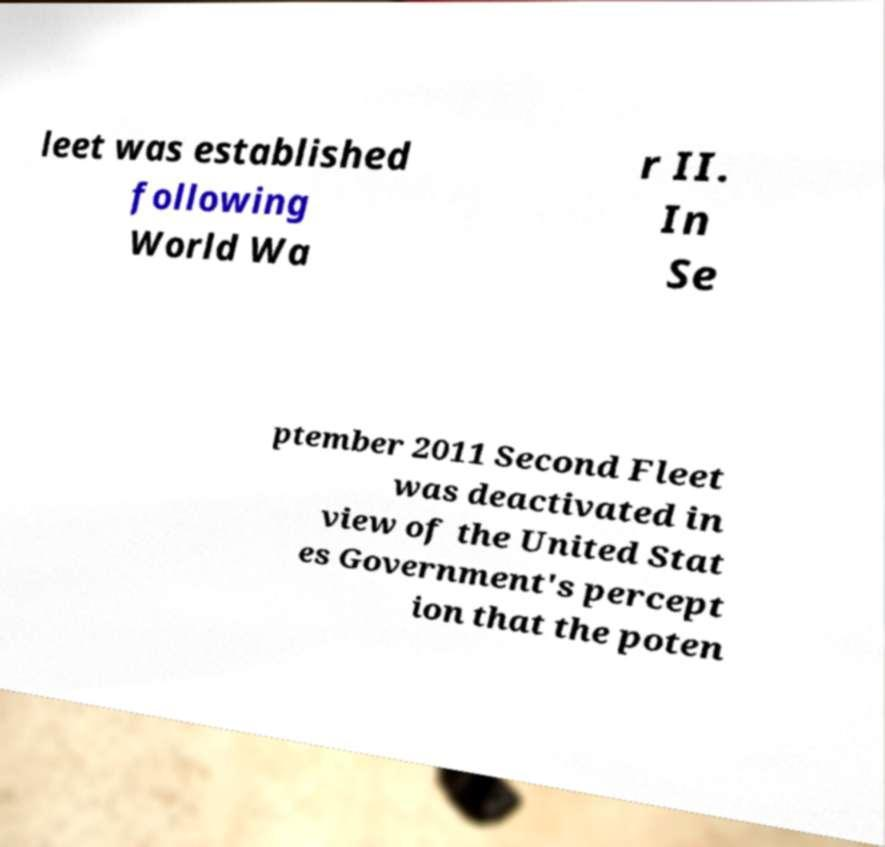Please read and relay the text visible in this image. What does it say? leet was established following World Wa r II. In Se ptember 2011 Second Fleet was deactivated in view of the United Stat es Government's percept ion that the poten 